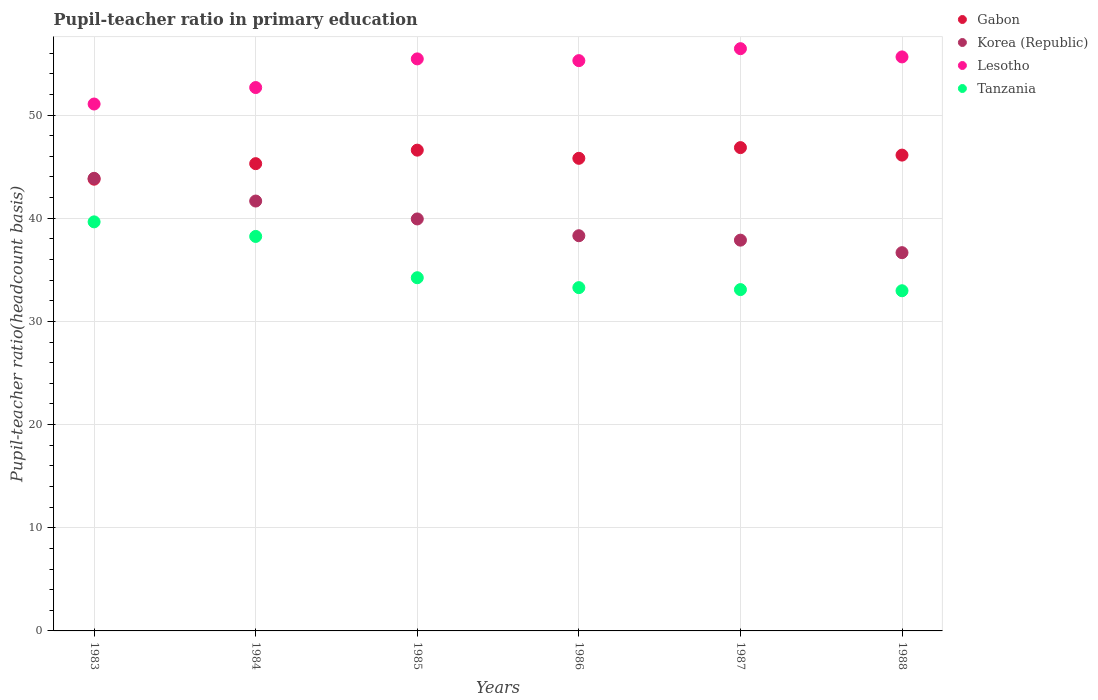How many different coloured dotlines are there?
Your response must be concise. 4. Is the number of dotlines equal to the number of legend labels?
Ensure brevity in your answer.  Yes. What is the pupil-teacher ratio in primary education in Korea (Republic) in 1983?
Offer a very short reply. 43.87. Across all years, what is the maximum pupil-teacher ratio in primary education in Lesotho?
Offer a very short reply. 56.44. Across all years, what is the minimum pupil-teacher ratio in primary education in Tanzania?
Ensure brevity in your answer.  32.97. In which year was the pupil-teacher ratio in primary education in Tanzania minimum?
Your answer should be very brief. 1988. What is the total pupil-teacher ratio in primary education in Korea (Republic) in the graph?
Ensure brevity in your answer.  238.33. What is the difference between the pupil-teacher ratio in primary education in Tanzania in 1984 and that in 1986?
Your answer should be very brief. 4.96. What is the difference between the pupil-teacher ratio in primary education in Korea (Republic) in 1984 and the pupil-teacher ratio in primary education in Lesotho in 1987?
Ensure brevity in your answer.  -14.77. What is the average pupil-teacher ratio in primary education in Korea (Republic) per year?
Your answer should be very brief. 39.72. In the year 1985, what is the difference between the pupil-teacher ratio in primary education in Lesotho and pupil-teacher ratio in primary education in Korea (Republic)?
Ensure brevity in your answer.  15.51. What is the ratio of the pupil-teacher ratio in primary education in Lesotho in 1985 to that in 1987?
Give a very brief answer. 0.98. What is the difference between the highest and the second highest pupil-teacher ratio in primary education in Korea (Republic)?
Ensure brevity in your answer.  2.2. What is the difference between the highest and the lowest pupil-teacher ratio in primary education in Lesotho?
Your answer should be compact. 5.36. In how many years, is the pupil-teacher ratio in primary education in Tanzania greater than the average pupil-teacher ratio in primary education in Tanzania taken over all years?
Make the answer very short. 2. Is the pupil-teacher ratio in primary education in Korea (Republic) strictly greater than the pupil-teacher ratio in primary education in Lesotho over the years?
Offer a terse response. No. Is the pupil-teacher ratio in primary education in Lesotho strictly less than the pupil-teacher ratio in primary education in Gabon over the years?
Offer a terse response. No. How many dotlines are there?
Give a very brief answer. 4. How many years are there in the graph?
Give a very brief answer. 6. Are the values on the major ticks of Y-axis written in scientific E-notation?
Provide a succinct answer. No. Does the graph contain grids?
Ensure brevity in your answer.  Yes. Where does the legend appear in the graph?
Your answer should be very brief. Top right. How many legend labels are there?
Offer a very short reply. 4. How are the legend labels stacked?
Your response must be concise. Vertical. What is the title of the graph?
Give a very brief answer. Pupil-teacher ratio in primary education. What is the label or title of the X-axis?
Offer a very short reply. Years. What is the label or title of the Y-axis?
Provide a succinct answer. Pupil-teacher ratio(headcount basis). What is the Pupil-teacher ratio(headcount basis) in Gabon in 1983?
Your response must be concise. 43.79. What is the Pupil-teacher ratio(headcount basis) in Korea (Republic) in 1983?
Provide a succinct answer. 43.87. What is the Pupil-teacher ratio(headcount basis) of Lesotho in 1983?
Keep it short and to the point. 51.07. What is the Pupil-teacher ratio(headcount basis) in Tanzania in 1983?
Provide a succinct answer. 39.65. What is the Pupil-teacher ratio(headcount basis) in Gabon in 1984?
Provide a succinct answer. 45.29. What is the Pupil-teacher ratio(headcount basis) of Korea (Republic) in 1984?
Your answer should be very brief. 41.67. What is the Pupil-teacher ratio(headcount basis) of Lesotho in 1984?
Provide a short and direct response. 52.67. What is the Pupil-teacher ratio(headcount basis) of Tanzania in 1984?
Offer a very short reply. 38.24. What is the Pupil-teacher ratio(headcount basis) in Gabon in 1985?
Provide a short and direct response. 46.6. What is the Pupil-teacher ratio(headcount basis) in Korea (Republic) in 1985?
Your answer should be very brief. 39.93. What is the Pupil-teacher ratio(headcount basis) of Lesotho in 1985?
Make the answer very short. 55.45. What is the Pupil-teacher ratio(headcount basis) of Tanzania in 1985?
Your answer should be very brief. 34.24. What is the Pupil-teacher ratio(headcount basis) in Gabon in 1986?
Your answer should be compact. 45.81. What is the Pupil-teacher ratio(headcount basis) of Korea (Republic) in 1986?
Your answer should be very brief. 38.31. What is the Pupil-teacher ratio(headcount basis) in Lesotho in 1986?
Make the answer very short. 55.28. What is the Pupil-teacher ratio(headcount basis) of Tanzania in 1986?
Your answer should be compact. 33.28. What is the Pupil-teacher ratio(headcount basis) in Gabon in 1987?
Your answer should be compact. 46.85. What is the Pupil-teacher ratio(headcount basis) of Korea (Republic) in 1987?
Your response must be concise. 37.88. What is the Pupil-teacher ratio(headcount basis) in Lesotho in 1987?
Your response must be concise. 56.44. What is the Pupil-teacher ratio(headcount basis) of Tanzania in 1987?
Provide a short and direct response. 33.09. What is the Pupil-teacher ratio(headcount basis) of Gabon in 1988?
Keep it short and to the point. 46.12. What is the Pupil-teacher ratio(headcount basis) in Korea (Republic) in 1988?
Give a very brief answer. 36.67. What is the Pupil-teacher ratio(headcount basis) of Lesotho in 1988?
Make the answer very short. 55.64. What is the Pupil-teacher ratio(headcount basis) of Tanzania in 1988?
Make the answer very short. 32.97. Across all years, what is the maximum Pupil-teacher ratio(headcount basis) of Gabon?
Make the answer very short. 46.85. Across all years, what is the maximum Pupil-teacher ratio(headcount basis) in Korea (Republic)?
Your answer should be very brief. 43.87. Across all years, what is the maximum Pupil-teacher ratio(headcount basis) of Lesotho?
Give a very brief answer. 56.44. Across all years, what is the maximum Pupil-teacher ratio(headcount basis) in Tanzania?
Give a very brief answer. 39.65. Across all years, what is the minimum Pupil-teacher ratio(headcount basis) in Gabon?
Make the answer very short. 43.79. Across all years, what is the minimum Pupil-teacher ratio(headcount basis) in Korea (Republic)?
Offer a very short reply. 36.67. Across all years, what is the minimum Pupil-teacher ratio(headcount basis) in Lesotho?
Provide a succinct answer. 51.07. Across all years, what is the minimum Pupil-teacher ratio(headcount basis) of Tanzania?
Your response must be concise. 32.97. What is the total Pupil-teacher ratio(headcount basis) of Gabon in the graph?
Offer a terse response. 274.46. What is the total Pupil-teacher ratio(headcount basis) in Korea (Republic) in the graph?
Your answer should be very brief. 238.33. What is the total Pupil-teacher ratio(headcount basis) of Lesotho in the graph?
Offer a very short reply. 326.55. What is the total Pupil-teacher ratio(headcount basis) in Tanzania in the graph?
Your response must be concise. 211.46. What is the difference between the Pupil-teacher ratio(headcount basis) in Gabon in 1983 and that in 1984?
Your answer should be compact. -1.51. What is the difference between the Pupil-teacher ratio(headcount basis) of Korea (Republic) in 1983 and that in 1984?
Provide a short and direct response. 2.2. What is the difference between the Pupil-teacher ratio(headcount basis) in Lesotho in 1983 and that in 1984?
Your answer should be very brief. -1.6. What is the difference between the Pupil-teacher ratio(headcount basis) in Tanzania in 1983 and that in 1984?
Your answer should be compact. 1.41. What is the difference between the Pupil-teacher ratio(headcount basis) in Gabon in 1983 and that in 1985?
Keep it short and to the point. -2.82. What is the difference between the Pupil-teacher ratio(headcount basis) of Korea (Republic) in 1983 and that in 1985?
Your response must be concise. 3.94. What is the difference between the Pupil-teacher ratio(headcount basis) in Lesotho in 1983 and that in 1985?
Your response must be concise. -4.37. What is the difference between the Pupil-teacher ratio(headcount basis) in Tanzania in 1983 and that in 1985?
Offer a terse response. 5.42. What is the difference between the Pupil-teacher ratio(headcount basis) in Gabon in 1983 and that in 1986?
Keep it short and to the point. -2.02. What is the difference between the Pupil-teacher ratio(headcount basis) of Korea (Republic) in 1983 and that in 1986?
Your answer should be very brief. 5.57. What is the difference between the Pupil-teacher ratio(headcount basis) of Lesotho in 1983 and that in 1986?
Make the answer very short. -4.21. What is the difference between the Pupil-teacher ratio(headcount basis) in Tanzania in 1983 and that in 1986?
Your answer should be compact. 6.37. What is the difference between the Pupil-teacher ratio(headcount basis) of Gabon in 1983 and that in 1987?
Give a very brief answer. -3.06. What is the difference between the Pupil-teacher ratio(headcount basis) of Korea (Republic) in 1983 and that in 1987?
Offer a very short reply. 5.99. What is the difference between the Pupil-teacher ratio(headcount basis) of Lesotho in 1983 and that in 1987?
Ensure brevity in your answer.  -5.36. What is the difference between the Pupil-teacher ratio(headcount basis) of Tanzania in 1983 and that in 1987?
Make the answer very short. 6.57. What is the difference between the Pupil-teacher ratio(headcount basis) of Gabon in 1983 and that in 1988?
Ensure brevity in your answer.  -2.33. What is the difference between the Pupil-teacher ratio(headcount basis) in Korea (Republic) in 1983 and that in 1988?
Provide a short and direct response. 7.21. What is the difference between the Pupil-teacher ratio(headcount basis) in Lesotho in 1983 and that in 1988?
Your response must be concise. -4.57. What is the difference between the Pupil-teacher ratio(headcount basis) of Tanzania in 1983 and that in 1988?
Offer a very short reply. 6.68. What is the difference between the Pupil-teacher ratio(headcount basis) in Gabon in 1984 and that in 1985?
Provide a short and direct response. -1.31. What is the difference between the Pupil-teacher ratio(headcount basis) of Korea (Republic) in 1984 and that in 1985?
Provide a succinct answer. 1.74. What is the difference between the Pupil-teacher ratio(headcount basis) of Lesotho in 1984 and that in 1985?
Ensure brevity in your answer.  -2.78. What is the difference between the Pupil-teacher ratio(headcount basis) of Tanzania in 1984 and that in 1985?
Your answer should be compact. 4. What is the difference between the Pupil-teacher ratio(headcount basis) of Gabon in 1984 and that in 1986?
Your response must be concise. -0.52. What is the difference between the Pupil-teacher ratio(headcount basis) in Korea (Republic) in 1984 and that in 1986?
Provide a short and direct response. 3.36. What is the difference between the Pupil-teacher ratio(headcount basis) of Lesotho in 1984 and that in 1986?
Give a very brief answer. -2.61. What is the difference between the Pupil-teacher ratio(headcount basis) in Tanzania in 1984 and that in 1986?
Your answer should be compact. 4.96. What is the difference between the Pupil-teacher ratio(headcount basis) in Gabon in 1984 and that in 1987?
Provide a short and direct response. -1.56. What is the difference between the Pupil-teacher ratio(headcount basis) of Korea (Republic) in 1984 and that in 1987?
Your answer should be very brief. 3.79. What is the difference between the Pupil-teacher ratio(headcount basis) in Lesotho in 1984 and that in 1987?
Make the answer very short. -3.77. What is the difference between the Pupil-teacher ratio(headcount basis) of Tanzania in 1984 and that in 1987?
Make the answer very short. 5.15. What is the difference between the Pupil-teacher ratio(headcount basis) in Gabon in 1984 and that in 1988?
Provide a succinct answer. -0.83. What is the difference between the Pupil-teacher ratio(headcount basis) of Korea (Republic) in 1984 and that in 1988?
Provide a short and direct response. 5. What is the difference between the Pupil-teacher ratio(headcount basis) of Lesotho in 1984 and that in 1988?
Your answer should be compact. -2.97. What is the difference between the Pupil-teacher ratio(headcount basis) in Tanzania in 1984 and that in 1988?
Your response must be concise. 5.27. What is the difference between the Pupil-teacher ratio(headcount basis) of Gabon in 1985 and that in 1986?
Your answer should be very brief. 0.79. What is the difference between the Pupil-teacher ratio(headcount basis) in Korea (Republic) in 1985 and that in 1986?
Ensure brevity in your answer.  1.63. What is the difference between the Pupil-teacher ratio(headcount basis) of Lesotho in 1985 and that in 1986?
Offer a terse response. 0.17. What is the difference between the Pupil-teacher ratio(headcount basis) in Tanzania in 1985 and that in 1986?
Ensure brevity in your answer.  0.96. What is the difference between the Pupil-teacher ratio(headcount basis) in Gabon in 1985 and that in 1987?
Provide a short and direct response. -0.25. What is the difference between the Pupil-teacher ratio(headcount basis) in Korea (Republic) in 1985 and that in 1987?
Offer a terse response. 2.06. What is the difference between the Pupil-teacher ratio(headcount basis) in Lesotho in 1985 and that in 1987?
Your answer should be very brief. -0.99. What is the difference between the Pupil-teacher ratio(headcount basis) of Tanzania in 1985 and that in 1987?
Keep it short and to the point. 1.15. What is the difference between the Pupil-teacher ratio(headcount basis) of Gabon in 1985 and that in 1988?
Give a very brief answer. 0.48. What is the difference between the Pupil-teacher ratio(headcount basis) in Korea (Republic) in 1985 and that in 1988?
Provide a succinct answer. 3.27. What is the difference between the Pupil-teacher ratio(headcount basis) of Lesotho in 1985 and that in 1988?
Your answer should be very brief. -0.19. What is the difference between the Pupil-teacher ratio(headcount basis) of Tanzania in 1985 and that in 1988?
Your answer should be compact. 1.26. What is the difference between the Pupil-teacher ratio(headcount basis) in Gabon in 1986 and that in 1987?
Ensure brevity in your answer.  -1.04. What is the difference between the Pupil-teacher ratio(headcount basis) of Korea (Republic) in 1986 and that in 1987?
Ensure brevity in your answer.  0.43. What is the difference between the Pupil-teacher ratio(headcount basis) in Lesotho in 1986 and that in 1987?
Your answer should be compact. -1.16. What is the difference between the Pupil-teacher ratio(headcount basis) of Tanzania in 1986 and that in 1987?
Give a very brief answer. 0.19. What is the difference between the Pupil-teacher ratio(headcount basis) in Gabon in 1986 and that in 1988?
Offer a very short reply. -0.31. What is the difference between the Pupil-teacher ratio(headcount basis) of Korea (Republic) in 1986 and that in 1988?
Give a very brief answer. 1.64. What is the difference between the Pupil-teacher ratio(headcount basis) in Lesotho in 1986 and that in 1988?
Ensure brevity in your answer.  -0.36. What is the difference between the Pupil-teacher ratio(headcount basis) of Tanzania in 1986 and that in 1988?
Your answer should be compact. 0.3. What is the difference between the Pupil-teacher ratio(headcount basis) in Gabon in 1987 and that in 1988?
Offer a terse response. 0.73. What is the difference between the Pupil-teacher ratio(headcount basis) of Korea (Republic) in 1987 and that in 1988?
Ensure brevity in your answer.  1.21. What is the difference between the Pupil-teacher ratio(headcount basis) of Lesotho in 1987 and that in 1988?
Your answer should be compact. 0.8. What is the difference between the Pupil-teacher ratio(headcount basis) in Tanzania in 1987 and that in 1988?
Ensure brevity in your answer.  0.11. What is the difference between the Pupil-teacher ratio(headcount basis) in Gabon in 1983 and the Pupil-teacher ratio(headcount basis) in Korea (Republic) in 1984?
Your response must be concise. 2.12. What is the difference between the Pupil-teacher ratio(headcount basis) in Gabon in 1983 and the Pupil-teacher ratio(headcount basis) in Lesotho in 1984?
Give a very brief answer. -8.88. What is the difference between the Pupil-teacher ratio(headcount basis) in Gabon in 1983 and the Pupil-teacher ratio(headcount basis) in Tanzania in 1984?
Ensure brevity in your answer.  5.55. What is the difference between the Pupil-teacher ratio(headcount basis) in Korea (Republic) in 1983 and the Pupil-teacher ratio(headcount basis) in Lesotho in 1984?
Your answer should be compact. -8.8. What is the difference between the Pupil-teacher ratio(headcount basis) of Korea (Republic) in 1983 and the Pupil-teacher ratio(headcount basis) of Tanzania in 1984?
Provide a succinct answer. 5.63. What is the difference between the Pupil-teacher ratio(headcount basis) in Lesotho in 1983 and the Pupil-teacher ratio(headcount basis) in Tanzania in 1984?
Provide a short and direct response. 12.84. What is the difference between the Pupil-teacher ratio(headcount basis) of Gabon in 1983 and the Pupil-teacher ratio(headcount basis) of Korea (Republic) in 1985?
Keep it short and to the point. 3.85. What is the difference between the Pupil-teacher ratio(headcount basis) of Gabon in 1983 and the Pupil-teacher ratio(headcount basis) of Lesotho in 1985?
Provide a succinct answer. -11.66. What is the difference between the Pupil-teacher ratio(headcount basis) in Gabon in 1983 and the Pupil-teacher ratio(headcount basis) in Tanzania in 1985?
Offer a very short reply. 9.55. What is the difference between the Pupil-teacher ratio(headcount basis) of Korea (Republic) in 1983 and the Pupil-teacher ratio(headcount basis) of Lesotho in 1985?
Ensure brevity in your answer.  -11.58. What is the difference between the Pupil-teacher ratio(headcount basis) of Korea (Republic) in 1983 and the Pupil-teacher ratio(headcount basis) of Tanzania in 1985?
Your response must be concise. 9.64. What is the difference between the Pupil-teacher ratio(headcount basis) in Lesotho in 1983 and the Pupil-teacher ratio(headcount basis) in Tanzania in 1985?
Your answer should be compact. 16.84. What is the difference between the Pupil-teacher ratio(headcount basis) in Gabon in 1983 and the Pupil-teacher ratio(headcount basis) in Korea (Republic) in 1986?
Provide a short and direct response. 5.48. What is the difference between the Pupil-teacher ratio(headcount basis) in Gabon in 1983 and the Pupil-teacher ratio(headcount basis) in Lesotho in 1986?
Provide a short and direct response. -11.49. What is the difference between the Pupil-teacher ratio(headcount basis) in Gabon in 1983 and the Pupil-teacher ratio(headcount basis) in Tanzania in 1986?
Provide a short and direct response. 10.51. What is the difference between the Pupil-teacher ratio(headcount basis) in Korea (Republic) in 1983 and the Pupil-teacher ratio(headcount basis) in Lesotho in 1986?
Provide a succinct answer. -11.41. What is the difference between the Pupil-teacher ratio(headcount basis) in Korea (Republic) in 1983 and the Pupil-teacher ratio(headcount basis) in Tanzania in 1986?
Offer a very short reply. 10.6. What is the difference between the Pupil-teacher ratio(headcount basis) of Lesotho in 1983 and the Pupil-teacher ratio(headcount basis) of Tanzania in 1986?
Your answer should be compact. 17.8. What is the difference between the Pupil-teacher ratio(headcount basis) of Gabon in 1983 and the Pupil-teacher ratio(headcount basis) of Korea (Republic) in 1987?
Your answer should be compact. 5.91. What is the difference between the Pupil-teacher ratio(headcount basis) in Gabon in 1983 and the Pupil-teacher ratio(headcount basis) in Lesotho in 1987?
Your answer should be very brief. -12.65. What is the difference between the Pupil-teacher ratio(headcount basis) in Gabon in 1983 and the Pupil-teacher ratio(headcount basis) in Tanzania in 1987?
Offer a terse response. 10.7. What is the difference between the Pupil-teacher ratio(headcount basis) of Korea (Republic) in 1983 and the Pupil-teacher ratio(headcount basis) of Lesotho in 1987?
Offer a very short reply. -12.57. What is the difference between the Pupil-teacher ratio(headcount basis) in Korea (Republic) in 1983 and the Pupil-teacher ratio(headcount basis) in Tanzania in 1987?
Offer a very short reply. 10.79. What is the difference between the Pupil-teacher ratio(headcount basis) in Lesotho in 1983 and the Pupil-teacher ratio(headcount basis) in Tanzania in 1987?
Keep it short and to the point. 17.99. What is the difference between the Pupil-teacher ratio(headcount basis) in Gabon in 1983 and the Pupil-teacher ratio(headcount basis) in Korea (Republic) in 1988?
Your response must be concise. 7.12. What is the difference between the Pupil-teacher ratio(headcount basis) of Gabon in 1983 and the Pupil-teacher ratio(headcount basis) of Lesotho in 1988?
Provide a succinct answer. -11.85. What is the difference between the Pupil-teacher ratio(headcount basis) in Gabon in 1983 and the Pupil-teacher ratio(headcount basis) in Tanzania in 1988?
Your answer should be compact. 10.81. What is the difference between the Pupil-teacher ratio(headcount basis) of Korea (Republic) in 1983 and the Pupil-teacher ratio(headcount basis) of Lesotho in 1988?
Give a very brief answer. -11.77. What is the difference between the Pupil-teacher ratio(headcount basis) of Korea (Republic) in 1983 and the Pupil-teacher ratio(headcount basis) of Tanzania in 1988?
Your response must be concise. 10.9. What is the difference between the Pupil-teacher ratio(headcount basis) of Lesotho in 1983 and the Pupil-teacher ratio(headcount basis) of Tanzania in 1988?
Ensure brevity in your answer.  18.1. What is the difference between the Pupil-teacher ratio(headcount basis) in Gabon in 1984 and the Pupil-teacher ratio(headcount basis) in Korea (Republic) in 1985?
Offer a terse response. 5.36. What is the difference between the Pupil-teacher ratio(headcount basis) of Gabon in 1984 and the Pupil-teacher ratio(headcount basis) of Lesotho in 1985?
Provide a short and direct response. -10.16. What is the difference between the Pupil-teacher ratio(headcount basis) in Gabon in 1984 and the Pupil-teacher ratio(headcount basis) in Tanzania in 1985?
Your answer should be compact. 11.06. What is the difference between the Pupil-teacher ratio(headcount basis) in Korea (Republic) in 1984 and the Pupil-teacher ratio(headcount basis) in Lesotho in 1985?
Provide a short and direct response. -13.78. What is the difference between the Pupil-teacher ratio(headcount basis) in Korea (Republic) in 1984 and the Pupil-teacher ratio(headcount basis) in Tanzania in 1985?
Make the answer very short. 7.43. What is the difference between the Pupil-teacher ratio(headcount basis) of Lesotho in 1984 and the Pupil-teacher ratio(headcount basis) of Tanzania in 1985?
Make the answer very short. 18.43. What is the difference between the Pupil-teacher ratio(headcount basis) of Gabon in 1984 and the Pupil-teacher ratio(headcount basis) of Korea (Republic) in 1986?
Provide a succinct answer. 6.99. What is the difference between the Pupil-teacher ratio(headcount basis) of Gabon in 1984 and the Pupil-teacher ratio(headcount basis) of Lesotho in 1986?
Offer a very short reply. -9.99. What is the difference between the Pupil-teacher ratio(headcount basis) in Gabon in 1984 and the Pupil-teacher ratio(headcount basis) in Tanzania in 1986?
Your answer should be very brief. 12.02. What is the difference between the Pupil-teacher ratio(headcount basis) in Korea (Republic) in 1984 and the Pupil-teacher ratio(headcount basis) in Lesotho in 1986?
Provide a succinct answer. -13.61. What is the difference between the Pupil-teacher ratio(headcount basis) in Korea (Republic) in 1984 and the Pupil-teacher ratio(headcount basis) in Tanzania in 1986?
Give a very brief answer. 8.39. What is the difference between the Pupil-teacher ratio(headcount basis) of Lesotho in 1984 and the Pupil-teacher ratio(headcount basis) of Tanzania in 1986?
Make the answer very short. 19.39. What is the difference between the Pupil-teacher ratio(headcount basis) of Gabon in 1984 and the Pupil-teacher ratio(headcount basis) of Korea (Republic) in 1987?
Keep it short and to the point. 7.41. What is the difference between the Pupil-teacher ratio(headcount basis) in Gabon in 1984 and the Pupil-teacher ratio(headcount basis) in Lesotho in 1987?
Ensure brevity in your answer.  -11.15. What is the difference between the Pupil-teacher ratio(headcount basis) of Gabon in 1984 and the Pupil-teacher ratio(headcount basis) of Tanzania in 1987?
Provide a succinct answer. 12.21. What is the difference between the Pupil-teacher ratio(headcount basis) of Korea (Republic) in 1984 and the Pupil-teacher ratio(headcount basis) of Lesotho in 1987?
Provide a short and direct response. -14.77. What is the difference between the Pupil-teacher ratio(headcount basis) in Korea (Republic) in 1984 and the Pupil-teacher ratio(headcount basis) in Tanzania in 1987?
Make the answer very short. 8.58. What is the difference between the Pupil-teacher ratio(headcount basis) in Lesotho in 1984 and the Pupil-teacher ratio(headcount basis) in Tanzania in 1987?
Your answer should be compact. 19.59. What is the difference between the Pupil-teacher ratio(headcount basis) in Gabon in 1984 and the Pupil-teacher ratio(headcount basis) in Korea (Republic) in 1988?
Offer a very short reply. 8.63. What is the difference between the Pupil-teacher ratio(headcount basis) of Gabon in 1984 and the Pupil-teacher ratio(headcount basis) of Lesotho in 1988?
Offer a terse response. -10.35. What is the difference between the Pupil-teacher ratio(headcount basis) in Gabon in 1984 and the Pupil-teacher ratio(headcount basis) in Tanzania in 1988?
Your answer should be very brief. 12.32. What is the difference between the Pupil-teacher ratio(headcount basis) in Korea (Republic) in 1984 and the Pupil-teacher ratio(headcount basis) in Lesotho in 1988?
Provide a short and direct response. -13.97. What is the difference between the Pupil-teacher ratio(headcount basis) of Korea (Republic) in 1984 and the Pupil-teacher ratio(headcount basis) of Tanzania in 1988?
Offer a terse response. 8.7. What is the difference between the Pupil-teacher ratio(headcount basis) of Lesotho in 1984 and the Pupil-teacher ratio(headcount basis) of Tanzania in 1988?
Make the answer very short. 19.7. What is the difference between the Pupil-teacher ratio(headcount basis) in Gabon in 1985 and the Pupil-teacher ratio(headcount basis) in Korea (Republic) in 1986?
Keep it short and to the point. 8.3. What is the difference between the Pupil-teacher ratio(headcount basis) in Gabon in 1985 and the Pupil-teacher ratio(headcount basis) in Lesotho in 1986?
Your answer should be compact. -8.68. What is the difference between the Pupil-teacher ratio(headcount basis) of Gabon in 1985 and the Pupil-teacher ratio(headcount basis) of Tanzania in 1986?
Your answer should be very brief. 13.33. What is the difference between the Pupil-teacher ratio(headcount basis) of Korea (Republic) in 1985 and the Pupil-teacher ratio(headcount basis) of Lesotho in 1986?
Your answer should be very brief. -15.35. What is the difference between the Pupil-teacher ratio(headcount basis) of Korea (Republic) in 1985 and the Pupil-teacher ratio(headcount basis) of Tanzania in 1986?
Your answer should be very brief. 6.66. What is the difference between the Pupil-teacher ratio(headcount basis) in Lesotho in 1985 and the Pupil-teacher ratio(headcount basis) in Tanzania in 1986?
Your response must be concise. 22.17. What is the difference between the Pupil-teacher ratio(headcount basis) in Gabon in 1985 and the Pupil-teacher ratio(headcount basis) in Korea (Republic) in 1987?
Offer a terse response. 8.72. What is the difference between the Pupil-teacher ratio(headcount basis) of Gabon in 1985 and the Pupil-teacher ratio(headcount basis) of Lesotho in 1987?
Your response must be concise. -9.84. What is the difference between the Pupil-teacher ratio(headcount basis) in Gabon in 1985 and the Pupil-teacher ratio(headcount basis) in Tanzania in 1987?
Ensure brevity in your answer.  13.52. What is the difference between the Pupil-teacher ratio(headcount basis) in Korea (Republic) in 1985 and the Pupil-teacher ratio(headcount basis) in Lesotho in 1987?
Offer a terse response. -16.5. What is the difference between the Pupil-teacher ratio(headcount basis) in Korea (Republic) in 1985 and the Pupil-teacher ratio(headcount basis) in Tanzania in 1987?
Your answer should be compact. 6.85. What is the difference between the Pupil-teacher ratio(headcount basis) in Lesotho in 1985 and the Pupil-teacher ratio(headcount basis) in Tanzania in 1987?
Offer a terse response. 22.36. What is the difference between the Pupil-teacher ratio(headcount basis) of Gabon in 1985 and the Pupil-teacher ratio(headcount basis) of Korea (Republic) in 1988?
Make the answer very short. 9.94. What is the difference between the Pupil-teacher ratio(headcount basis) of Gabon in 1985 and the Pupil-teacher ratio(headcount basis) of Lesotho in 1988?
Offer a very short reply. -9.04. What is the difference between the Pupil-teacher ratio(headcount basis) in Gabon in 1985 and the Pupil-teacher ratio(headcount basis) in Tanzania in 1988?
Make the answer very short. 13.63. What is the difference between the Pupil-teacher ratio(headcount basis) of Korea (Republic) in 1985 and the Pupil-teacher ratio(headcount basis) of Lesotho in 1988?
Keep it short and to the point. -15.71. What is the difference between the Pupil-teacher ratio(headcount basis) in Korea (Republic) in 1985 and the Pupil-teacher ratio(headcount basis) in Tanzania in 1988?
Keep it short and to the point. 6.96. What is the difference between the Pupil-teacher ratio(headcount basis) in Lesotho in 1985 and the Pupil-teacher ratio(headcount basis) in Tanzania in 1988?
Give a very brief answer. 22.47. What is the difference between the Pupil-teacher ratio(headcount basis) of Gabon in 1986 and the Pupil-teacher ratio(headcount basis) of Korea (Republic) in 1987?
Offer a very short reply. 7.93. What is the difference between the Pupil-teacher ratio(headcount basis) of Gabon in 1986 and the Pupil-teacher ratio(headcount basis) of Lesotho in 1987?
Your answer should be compact. -10.63. What is the difference between the Pupil-teacher ratio(headcount basis) of Gabon in 1986 and the Pupil-teacher ratio(headcount basis) of Tanzania in 1987?
Keep it short and to the point. 12.72. What is the difference between the Pupil-teacher ratio(headcount basis) in Korea (Republic) in 1986 and the Pupil-teacher ratio(headcount basis) in Lesotho in 1987?
Provide a short and direct response. -18.13. What is the difference between the Pupil-teacher ratio(headcount basis) of Korea (Republic) in 1986 and the Pupil-teacher ratio(headcount basis) of Tanzania in 1987?
Offer a very short reply. 5.22. What is the difference between the Pupil-teacher ratio(headcount basis) in Lesotho in 1986 and the Pupil-teacher ratio(headcount basis) in Tanzania in 1987?
Give a very brief answer. 22.19. What is the difference between the Pupil-teacher ratio(headcount basis) in Gabon in 1986 and the Pupil-teacher ratio(headcount basis) in Korea (Republic) in 1988?
Keep it short and to the point. 9.14. What is the difference between the Pupil-teacher ratio(headcount basis) of Gabon in 1986 and the Pupil-teacher ratio(headcount basis) of Lesotho in 1988?
Offer a very short reply. -9.83. What is the difference between the Pupil-teacher ratio(headcount basis) of Gabon in 1986 and the Pupil-teacher ratio(headcount basis) of Tanzania in 1988?
Give a very brief answer. 12.84. What is the difference between the Pupil-teacher ratio(headcount basis) in Korea (Republic) in 1986 and the Pupil-teacher ratio(headcount basis) in Lesotho in 1988?
Keep it short and to the point. -17.33. What is the difference between the Pupil-teacher ratio(headcount basis) of Korea (Republic) in 1986 and the Pupil-teacher ratio(headcount basis) of Tanzania in 1988?
Provide a short and direct response. 5.33. What is the difference between the Pupil-teacher ratio(headcount basis) in Lesotho in 1986 and the Pupil-teacher ratio(headcount basis) in Tanzania in 1988?
Make the answer very short. 22.31. What is the difference between the Pupil-teacher ratio(headcount basis) of Gabon in 1987 and the Pupil-teacher ratio(headcount basis) of Korea (Republic) in 1988?
Provide a succinct answer. 10.18. What is the difference between the Pupil-teacher ratio(headcount basis) of Gabon in 1987 and the Pupil-teacher ratio(headcount basis) of Lesotho in 1988?
Offer a terse response. -8.79. What is the difference between the Pupil-teacher ratio(headcount basis) of Gabon in 1987 and the Pupil-teacher ratio(headcount basis) of Tanzania in 1988?
Provide a succinct answer. 13.87. What is the difference between the Pupil-teacher ratio(headcount basis) in Korea (Republic) in 1987 and the Pupil-teacher ratio(headcount basis) in Lesotho in 1988?
Ensure brevity in your answer.  -17.76. What is the difference between the Pupil-teacher ratio(headcount basis) of Korea (Republic) in 1987 and the Pupil-teacher ratio(headcount basis) of Tanzania in 1988?
Provide a short and direct response. 4.9. What is the difference between the Pupil-teacher ratio(headcount basis) of Lesotho in 1987 and the Pupil-teacher ratio(headcount basis) of Tanzania in 1988?
Make the answer very short. 23.46. What is the average Pupil-teacher ratio(headcount basis) in Gabon per year?
Provide a short and direct response. 45.74. What is the average Pupil-teacher ratio(headcount basis) of Korea (Republic) per year?
Provide a short and direct response. 39.72. What is the average Pupil-teacher ratio(headcount basis) of Lesotho per year?
Your answer should be compact. 54.43. What is the average Pupil-teacher ratio(headcount basis) in Tanzania per year?
Offer a very short reply. 35.24. In the year 1983, what is the difference between the Pupil-teacher ratio(headcount basis) of Gabon and Pupil-teacher ratio(headcount basis) of Korea (Republic)?
Keep it short and to the point. -0.09. In the year 1983, what is the difference between the Pupil-teacher ratio(headcount basis) in Gabon and Pupil-teacher ratio(headcount basis) in Lesotho?
Make the answer very short. -7.29. In the year 1983, what is the difference between the Pupil-teacher ratio(headcount basis) in Gabon and Pupil-teacher ratio(headcount basis) in Tanzania?
Ensure brevity in your answer.  4.14. In the year 1983, what is the difference between the Pupil-teacher ratio(headcount basis) of Korea (Republic) and Pupil-teacher ratio(headcount basis) of Lesotho?
Keep it short and to the point. -7.2. In the year 1983, what is the difference between the Pupil-teacher ratio(headcount basis) of Korea (Republic) and Pupil-teacher ratio(headcount basis) of Tanzania?
Your answer should be very brief. 4.22. In the year 1983, what is the difference between the Pupil-teacher ratio(headcount basis) in Lesotho and Pupil-teacher ratio(headcount basis) in Tanzania?
Your answer should be compact. 11.42. In the year 1984, what is the difference between the Pupil-teacher ratio(headcount basis) in Gabon and Pupil-teacher ratio(headcount basis) in Korea (Republic)?
Your answer should be compact. 3.62. In the year 1984, what is the difference between the Pupil-teacher ratio(headcount basis) in Gabon and Pupil-teacher ratio(headcount basis) in Lesotho?
Your response must be concise. -7.38. In the year 1984, what is the difference between the Pupil-teacher ratio(headcount basis) in Gabon and Pupil-teacher ratio(headcount basis) in Tanzania?
Your answer should be compact. 7.05. In the year 1984, what is the difference between the Pupil-teacher ratio(headcount basis) in Korea (Republic) and Pupil-teacher ratio(headcount basis) in Lesotho?
Give a very brief answer. -11. In the year 1984, what is the difference between the Pupil-teacher ratio(headcount basis) in Korea (Republic) and Pupil-teacher ratio(headcount basis) in Tanzania?
Offer a very short reply. 3.43. In the year 1984, what is the difference between the Pupil-teacher ratio(headcount basis) of Lesotho and Pupil-teacher ratio(headcount basis) of Tanzania?
Provide a succinct answer. 14.43. In the year 1985, what is the difference between the Pupil-teacher ratio(headcount basis) in Gabon and Pupil-teacher ratio(headcount basis) in Korea (Republic)?
Give a very brief answer. 6.67. In the year 1985, what is the difference between the Pupil-teacher ratio(headcount basis) of Gabon and Pupil-teacher ratio(headcount basis) of Lesotho?
Your answer should be compact. -8.85. In the year 1985, what is the difference between the Pupil-teacher ratio(headcount basis) of Gabon and Pupil-teacher ratio(headcount basis) of Tanzania?
Provide a succinct answer. 12.37. In the year 1985, what is the difference between the Pupil-teacher ratio(headcount basis) in Korea (Republic) and Pupil-teacher ratio(headcount basis) in Lesotho?
Offer a very short reply. -15.51. In the year 1985, what is the difference between the Pupil-teacher ratio(headcount basis) in Korea (Republic) and Pupil-teacher ratio(headcount basis) in Tanzania?
Give a very brief answer. 5.7. In the year 1985, what is the difference between the Pupil-teacher ratio(headcount basis) of Lesotho and Pupil-teacher ratio(headcount basis) of Tanzania?
Give a very brief answer. 21.21. In the year 1986, what is the difference between the Pupil-teacher ratio(headcount basis) in Gabon and Pupil-teacher ratio(headcount basis) in Korea (Republic)?
Your answer should be compact. 7.5. In the year 1986, what is the difference between the Pupil-teacher ratio(headcount basis) in Gabon and Pupil-teacher ratio(headcount basis) in Lesotho?
Make the answer very short. -9.47. In the year 1986, what is the difference between the Pupil-teacher ratio(headcount basis) in Gabon and Pupil-teacher ratio(headcount basis) in Tanzania?
Provide a succinct answer. 12.53. In the year 1986, what is the difference between the Pupil-teacher ratio(headcount basis) in Korea (Republic) and Pupil-teacher ratio(headcount basis) in Lesotho?
Provide a short and direct response. -16.97. In the year 1986, what is the difference between the Pupil-teacher ratio(headcount basis) in Korea (Republic) and Pupil-teacher ratio(headcount basis) in Tanzania?
Offer a terse response. 5.03. In the year 1986, what is the difference between the Pupil-teacher ratio(headcount basis) of Lesotho and Pupil-teacher ratio(headcount basis) of Tanzania?
Provide a short and direct response. 22. In the year 1987, what is the difference between the Pupil-teacher ratio(headcount basis) in Gabon and Pupil-teacher ratio(headcount basis) in Korea (Republic)?
Provide a short and direct response. 8.97. In the year 1987, what is the difference between the Pupil-teacher ratio(headcount basis) of Gabon and Pupil-teacher ratio(headcount basis) of Lesotho?
Offer a very short reply. -9.59. In the year 1987, what is the difference between the Pupil-teacher ratio(headcount basis) of Gabon and Pupil-teacher ratio(headcount basis) of Tanzania?
Provide a succinct answer. 13.76. In the year 1987, what is the difference between the Pupil-teacher ratio(headcount basis) in Korea (Republic) and Pupil-teacher ratio(headcount basis) in Lesotho?
Your answer should be very brief. -18.56. In the year 1987, what is the difference between the Pupil-teacher ratio(headcount basis) in Korea (Republic) and Pupil-teacher ratio(headcount basis) in Tanzania?
Provide a short and direct response. 4.79. In the year 1987, what is the difference between the Pupil-teacher ratio(headcount basis) of Lesotho and Pupil-teacher ratio(headcount basis) of Tanzania?
Make the answer very short. 23.35. In the year 1988, what is the difference between the Pupil-teacher ratio(headcount basis) in Gabon and Pupil-teacher ratio(headcount basis) in Korea (Republic)?
Ensure brevity in your answer.  9.46. In the year 1988, what is the difference between the Pupil-teacher ratio(headcount basis) in Gabon and Pupil-teacher ratio(headcount basis) in Lesotho?
Your answer should be compact. -9.52. In the year 1988, what is the difference between the Pupil-teacher ratio(headcount basis) of Gabon and Pupil-teacher ratio(headcount basis) of Tanzania?
Give a very brief answer. 13.15. In the year 1988, what is the difference between the Pupil-teacher ratio(headcount basis) in Korea (Republic) and Pupil-teacher ratio(headcount basis) in Lesotho?
Your response must be concise. -18.97. In the year 1988, what is the difference between the Pupil-teacher ratio(headcount basis) in Korea (Republic) and Pupil-teacher ratio(headcount basis) in Tanzania?
Your response must be concise. 3.69. In the year 1988, what is the difference between the Pupil-teacher ratio(headcount basis) in Lesotho and Pupil-teacher ratio(headcount basis) in Tanzania?
Offer a very short reply. 22.67. What is the ratio of the Pupil-teacher ratio(headcount basis) of Gabon in 1983 to that in 1984?
Provide a short and direct response. 0.97. What is the ratio of the Pupil-teacher ratio(headcount basis) of Korea (Republic) in 1983 to that in 1984?
Make the answer very short. 1.05. What is the ratio of the Pupil-teacher ratio(headcount basis) in Lesotho in 1983 to that in 1984?
Offer a terse response. 0.97. What is the ratio of the Pupil-teacher ratio(headcount basis) in Tanzania in 1983 to that in 1984?
Keep it short and to the point. 1.04. What is the ratio of the Pupil-teacher ratio(headcount basis) in Gabon in 1983 to that in 1985?
Offer a terse response. 0.94. What is the ratio of the Pupil-teacher ratio(headcount basis) in Korea (Republic) in 1983 to that in 1985?
Your answer should be compact. 1.1. What is the ratio of the Pupil-teacher ratio(headcount basis) in Lesotho in 1983 to that in 1985?
Provide a succinct answer. 0.92. What is the ratio of the Pupil-teacher ratio(headcount basis) of Tanzania in 1983 to that in 1985?
Your response must be concise. 1.16. What is the ratio of the Pupil-teacher ratio(headcount basis) in Gabon in 1983 to that in 1986?
Your answer should be compact. 0.96. What is the ratio of the Pupil-teacher ratio(headcount basis) of Korea (Republic) in 1983 to that in 1986?
Your answer should be very brief. 1.15. What is the ratio of the Pupil-teacher ratio(headcount basis) of Lesotho in 1983 to that in 1986?
Your response must be concise. 0.92. What is the ratio of the Pupil-teacher ratio(headcount basis) of Tanzania in 1983 to that in 1986?
Your answer should be very brief. 1.19. What is the ratio of the Pupil-teacher ratio(headcount basis) in Gabon in 1983 to that in 1987?
Provide a succinct answer. 0.93. What is the ratio of the Pupil-teacher ratio(headcount basis) in Korea (Republic) in 1983 to that in 1987?
Your answer should be very brief. 1.16. What is the ratio of the Pupil-teacher ratio(headcount basis) in Lesotho in 1983 to that in 1987?
Offer a terse response. 0.91. What is the ratio of the Pupil-teacher ratio(headcount basis) of Tanzania in 1983 to that in 1987?
Keep it short and to the point. 1.2. What is the ratio of the Pupil-teacher ratio(headcount basis) of Gabon in 1983 to that in 1988?
Provide a succinct answer. 0.95. What is the ratio of the Pupil-teacher ratio(headcount basis) in Korea (Republic) in 1983 to that in 1988?
Ensure brevity in your answer.  1.2. What is the ratio of the Pupil-teacher ratio(headcount basis) of Lesotho in 1983 to that in 1988?
Offer a very short reply. 0.92. What is the ratio of the Pupil-teacher ratio(headcount basis) of Tanzania in 1983 to that in 1988?
Give a very brief answer. 1.2. What is the ratio of the Pupil-teacher ratio(headcount basis) of Gabon in 1984 to that in 1985?
Your answer should be very brief. 0.97. What is the ratio of the Pupil-teacher ratio(headcount basis) of Korea (Republic) in 1984 to that in 1985?
Offer a terse response. 1.04. What is the ratio of the Pupil-teacher ratio(headcount basis) of Lesotho in 1984 to that in 1985?
Give a very brief answer. 0.95. What is the ratio of the Pupil-teacher ratio(headcount basis) in Tanzania in 1984 to that in 1985?
Your answer should be compact. 1.12. What is the ratio of the Pupil-teacher ratio(headcount basis) in Gabon in 1984 to that in 1986?
Keep it short and to the point. 0.99. What is the ratio of the Pupil-teacher ratio(headcount basis) in Korea (Republic) in 1984 to that in 1986?
Keep it short and to the point. 1.09. What is the ratio of the Pupil-teacher ratio(headcount basis) of Lesotho in 1984 to that in 1986?
Your answer should be very brief. 0.95. What is the ratio of the Pupil-teacher ratio(headcount basis) in Tanzania in 1984 to that in 1986?
Offer a very short reply. 1.15. What is the ratio of the Pupil-teacher ratio(headcount basis) of Gabon in 1984 to that in 1987?
Offer a very short reply. 0.97. What is the ratio of the Pupil-teacher ratio(headcount basis) of Korea (Republic) in 1984 to that in 1987?
Provide a short and direct response. 1.1. What is the ratio of the Pupil-teacher ratio(headcount basis) of Lesotho in 1984 to that in 1987?
Your answer should be very brief. 0.93. What is the ratio of the Pupil-teacher ratio(headcount basis) in Tanzania in 1984 to that in 1987?
Make the answer very short. 1.16. What is the ratio of the Pupil-teacher ratio(headcount basis) of Korea (Republic) in 1984 to that in 1988?
Your response must be concise. 1.14. What is the ratio of the Pupil-teacher ratio(headcount basis) of Lesotho in 1984 to that in 1988?
Ensure brevity in your answer.  0.95. What is the ratio of the Pupil-teacher ratio(headcount basis) in Tanzania in 1984 to that in 1988?
Offer a very short reply. 1.16. What is the ratio of the Pupil-teacher ratio(headcount basis) of Gabon in 1985 to that in 1986?
Make the answer very short. 1.02. What is the ratio of the Pupil-teacher ratio(headcount basis) in Korea (Republic) in 1985 to that in 1986?
Give a very brief answer. 1.04. What is the ratio of the Pupil-teacher ratio(headcount basis) in Tanzania in 1985 to that in 1986?
Ensure brevity in your answer.  1.03. What is the ratio of the Pupil-teacher ratio(headcount basis) of Gabon in 1985 to that in 1987?
Offer a terse response. 0.99. What is the ratio of the Pupil-teacher ratio(headcount basis) of Korea (Republic) in 1985 to that in 1987?
Provide a succinct answer. 1.05. What is the ratio of the Pupil-teacher ratio(headcount basis) of Lesotho in 1985 to that in 1987?
Offer a terse response. 0.98. What is the ratio of the Pupil-teacher ratio(headcount basis) of Tanzania in 1985 to that in 1987?
Keep it short and to the point. 1.03. What is the ratio of the Pupil-teacher ratio(headcount basis) in Gabon in 1985 to that in 1988?
Your answer should be compact. 1.01. What is the ratio of the Pupil-teacher ratio(headcount basis) in Korea (Republic) in 1985 to that in 1988?
Make the answer very short. 1.09. What is the ratio of the Pupil-teacher ratio(headcount basis) in Lesotho in 1985 to that in 1988?
Your answer should be very brief. 1. What is the ratio of the Pupil-teacher ratio(headcount basis) of Tanzania in 1985 to that in 1988?
Provide a short and direct response. 1.04. What is the ratio of the Pupil-teacher ratio(headcount basis) in Gabon in 1986 to that in 1987?
Your answer should be compact. 0.98. What is the ratio of the Pupil-teacher ratio(headcount basis) of Korea (Republic) in 1986 to that in 1987?
Offer a terse response. 1.01. What is the ratio of the Pupil-teacher ratio(headcount basis) in Lesotho in 1986 to that in 1987?
Provide a succinct answer. 0.98. What is the ratio of the Pupil-teacher ratio(headcount basis) in Korea (Republic) in 1986 to that in 1988?
Give a very brief answer. 1.04. What is the ratio of the Pupil-teacher ratio(headcount basis) of Tanzania in 1986 to that in 1988?
Give a very brief answer. 1.01. What is the ratio of the Pupil-teacher ratio(headcount basis) of Gabon in 1987 to that in 1988?
Your response must be concise. 1.02. What is the ratio of the Pupil-teacher ratio(headcount basis) of Korea (Republic) in 1987 to that in 1988?
Offer a very short reply. 1.03. What is the ratio of the Pupil-teacher ratio(headcount basis) of Lesotho in 1987 to that in 1988?
Keep it short and to the point. 1.01. What is the difference between the highest and the second highest Pupil-teacher ratio(headcount basis) in Gabon?
Your response must be concise. 0.25. What is the difference between the highest and the second highest Pupil-teacher ratio(headcount basis) of Korea (Republic)?
Offer a very short reply. 2.2. What is the difference between the highest and the second highest Pupil-teacher ratio(headcount basis) of Lesotho?
Keep it short and to the point. 0.8. What is the difference between the highest and the second highest Pupil-teacher ratio(headcount basis) of Tanzania?
Ensure brevity in your answer.  1.41. What is the difference between the highest and the lowest Pupil-teacher ratio(headcount basis) in Gabon?
Your answer should be compact. 3.06. What is the difference between the highest and the lowest Pupil-teacher ratio(headcount basis) in Korea (Republic)?
Keep it short and to the point. 7.21. What is the difference between the highest and the lowest Pupil-teacher ratio(headcount basis) in Lesotho?
Provide a short and direct response. 5.36. What is the difference between the highest and the lowest Pupil-teacher ratio(headcount basis) of Tanzania?
Offer a very short reply. 6.68. 